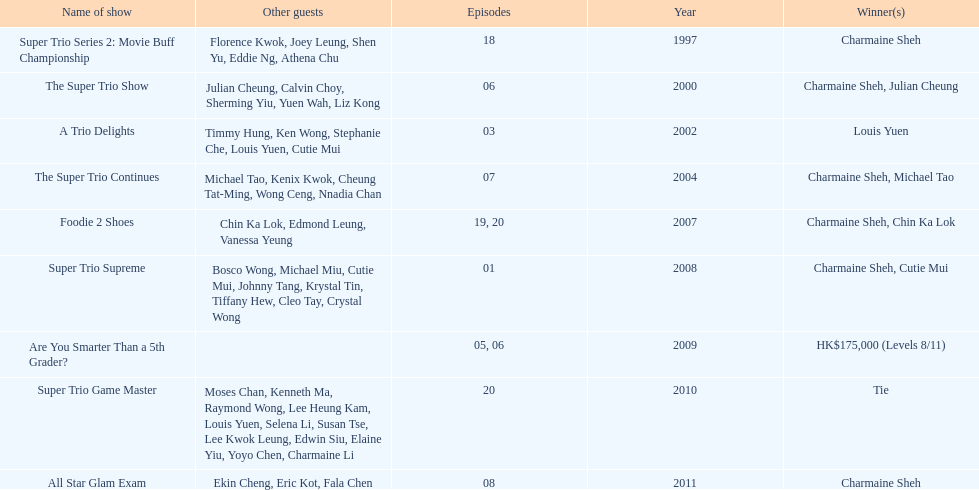How many consecutive trio shows did charmaine sheh do before being on another variety program? 34. 